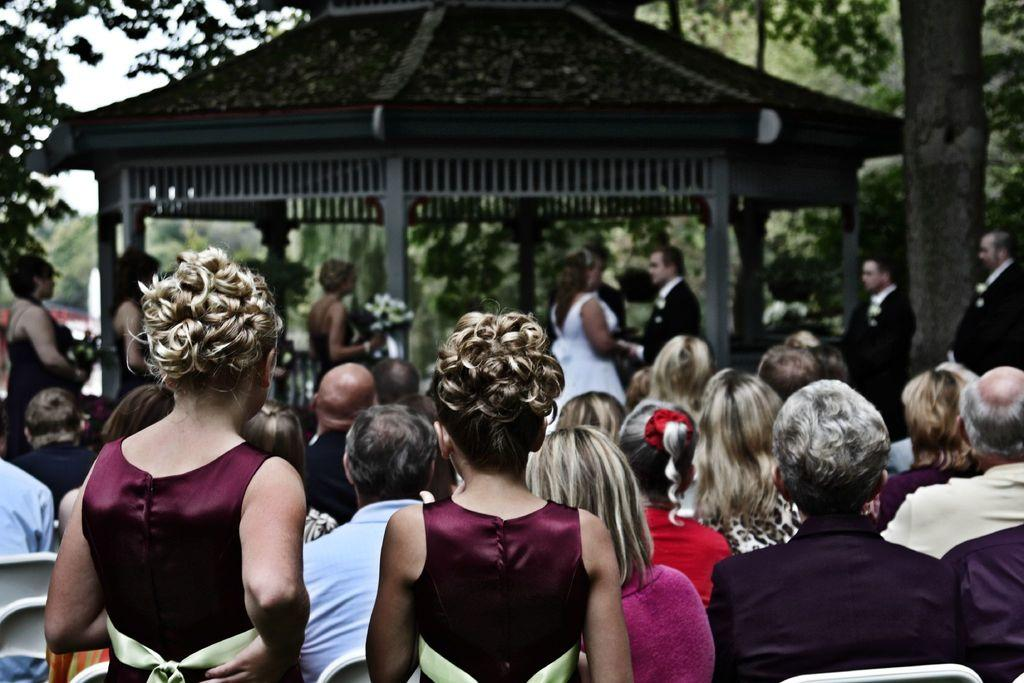How many groups of people can be seen in the image? There are two groups of people in the image, one in the foreground and one in the background. What structures are visible in the background of the image? There are pillars, a hut, and trees visible in the background of the image. What is visible at the top of the image? The sky is visible at the top of the image. What type of behavior can be observed in the house in the image? There is no house present in the image; it features a group of people, pillars, a hut, trees, and the sky. 